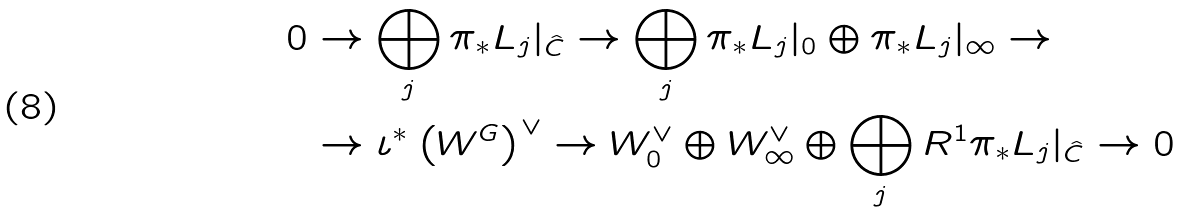<formula> <loc_0><loc_0><loc_500><loc_500>0 & \rightarrow \bigoplus _ { j } \pi _ { * } L _ { j } | _ { \hat { C } } \rightarrow \bigoplus _ { j } \pi _ { * } L _ { j } | _ { 0 } \oplus \pi _ { * } L _ { j } | _ { \infty } \rightarrow \\ & \rightarrow \iota ^ { * } \left ( W ^ { G } \right ) ^ { \vee } \rightarrow W _ { 0 } ^ { \vee } \oplus W _ { \infty } ^ { \vee } \oplus \bigoplus _ { j } R ^ { 1 } \pi _ { * } L _ { j } | _ { \hat { C } } \rightarrow 0</formula> 